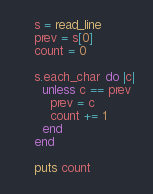<code> <loc_0><loc_0><loc_500><loc_500><_Crystal_>    s = read_line
    prev = s[0]
    count = 0

    s.each_char do |c|
      unless c == prev
        prev = c
        count += 1
      end
    end

    puts count</code> 